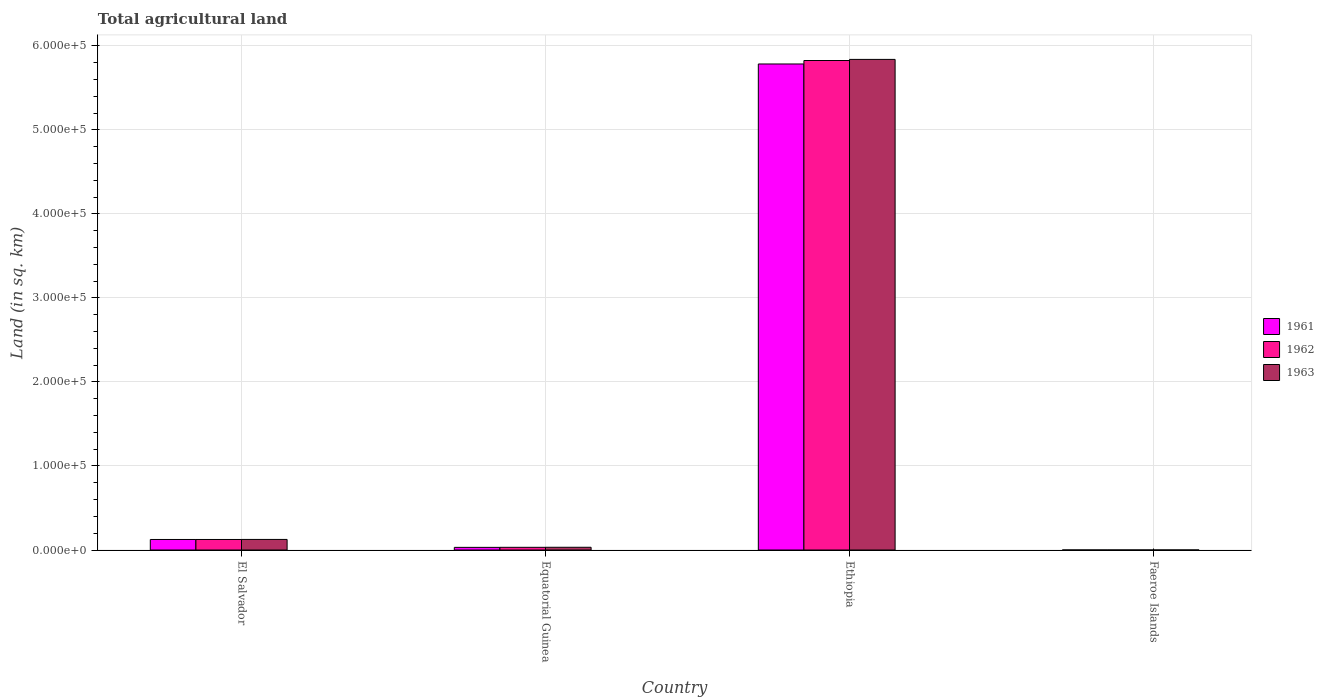How many different coloured bars are there?
Offer a terse response. 3. How many groups of bars are there?
Provide a short and direct response. 4. Are the number of bars per tick equal to the number of legend labels?
Your answer should be compact. Yes. Are the number of bars on each tick of the X-axis equal?
Offer a terse response. Yes. How many bars are there on the 1st tick from the left?
Offer a very short reply. 3. How many bars are there on the 3rd tick from the right?
Your answer should be compact. 3. What is the label of the 2nd group of bars from the left?
Keep it short and to the point. Equatorial Guinea. In how many cases, is the number of bars for a given country not equal to the number of legend labels?
Your answer should be very brief. 0. What is the total agricultural land in 1963 in Equatorial Guinea?
Keep it short and to the point. 3240. Across all countries, what is the maximum total agricultural land in 1963?
Provide a succinct answer. 5.84e+05. Across all countries, what is the minimum total agricultural land in 1961?
Your answer should be compact. 30. In which country was the total agricultural land in 1963 maximum?
Your response must be concise. Ethiopia. In which country was the total agricultural land in 1962 minimum?
Your response must be concise. Faeroe Islands. What is the total total agricultural land in 1963 in the graph?
Your answer should be very brief. 6.00e+05. What is the difference between the total agricultural land in 1963 in El Salvador and that in Faeroe Islands?
Provide a short and direct response. 1.26e+04. What is the difference between the total agricultural land in 1961 in Faeroe Islands and the total agricultural land in 1962 in El Salvador?
Provide a succinct answer. -1.25e+04. What is the average total agricultural land in 1961 per country?
Provide a succinct answer. 1.49e+05. What is the difference between the total agricultural land of/in 1961 and total agricultural land of/in 1963 in Equatorial Guinea?
Offer a terse response. -100. In how many countries, is the total agricultural land in 1962 greater than 120000 sq.km?
Your answer should be compact. 1. What is the ratio of the total agricultural land in 1962 in Equatorial Guinea to that in Ethiopia?
Provide a short and direct response. 0.01. Is the total agricultural land in 1963 in Equatorial Guinea less than that in Ethiopia?
Your answer should be compact. Yes. Is the difference between the total agricultural land in 1961 in Equatorial Guinea and Ethiopia greater than the difference between the total agricultural land in 1963 in Equatorial Guinea and Ethiopia?
Provide a short and direct response. Yes. What is the difference between the highest and the second highest total agricultural land in 1963?
Offer a terse response. 5.71e+05. What is the difference between the highest and the lowest total agricultural land in 1962?
Offer a terse response. 5.82e+05. In how many countries, is the total agricultural land in 1963 greater than the average total agricultural land in 1963 taken over all countries?
Provide a short and direct response. 1. Is the sum of the total agricultural land in 1961 in El Salvador and Faeroe Islands greater than the maximum total agricultural land in 1962 across all countries?
Your answer should be very brief. No. Is it the case that in every country, the sum of the total agricultural land in 1962 and total agricultural land in 1961 is greater than the total agricultural land in 1963?
Your answer should be very brief. Yes. Are all the bars in the graph horizontal?
Provide a succinct answer. No. How many countries are there in the graph?
Offer a terse response. 4. Are the values on the major ticks of Y-axis written in scientific E-notation?
Your answer should be very brief. Yes. Does the graph contain grids?
Provide a succinct answer. Yes. Where does the legend appear in the graph?
Ensure brevity in your answer.  Center right. How many legend labels are there?
Your answer should be very brief. 3. What is the title of the graph?
Offer a terse response. Total agricultural land. Does "1967" appear as one of the legend labels in the graph?
Your answer should be very brief. No. What is the label or title of the Y-axis?
Your answer should be very brief. Land (in sq. km). What is the Land (in sq. km) in 1961 in El Salvador?
Give a very brief answer. 1.25e+04. What is the Land (in sq. km) in 1962 in El Salvador?
Make the answer very short. 1.25e+04. What is the Land (in sq. km) in 1963 in El Salvador?
Offer a terse response. 1.26e+04. What is the Land (in sq. km) in 1961 in Equatorial Guinea?
Offer a terse response. 3140. What is the Land (in sq. km) of 1962 in Equatorial Guinea?
Provide a succinct answer. 3190. What is the Land (in sq. km) in 1963 in Equatorial Guinea?
Give a very brief answer. 3240. What is the Land (in sq. km) in 1961 in Ethiopia?
Your answer should be compact. 5.78e+05. What is the Land (in sq. km) of 1962 in Ethiopia?
Provide a succinct answer. 5.82e+05. What is the Land (in sq. km) of 1963 in Ethiopia?
Provide a succinct answer. 5.84e+05. What is the Land (in sq. km) of 1962 in Faeroe Islands?
Your response must be concise. 30. What is the Land (in sq. km) in 1963 in Faeroe Islands?
Offer a terse response. 30. Across all countries, what is the maximum Land (in sq. km) of 1961?
Give a very brief answer. 5.78e+05. Across all countries, what is the maximum Land (in sq. km) in 1962?
Make the answer very short. 5.82e+05. Across all countries, what is the maximum Land (in sq. km) in 1963?
Your answer should be compact. 5.84e+05. Across all countries, what is the minimum Land (in sq. km) in 1961?
Keep it short and to the point. 30. Across all countries, what is the minimum Land (in sq. km) in 1963?
Provide a short and direct response. 30. What is the total Land (in sq. km) in 1961 in the graph?
Your answer should be compact. 5.94e+05. What is the total Land (in sq. km) in 1962 in the graph?
Your response must be concise. 5.98e+05. What is the total Land (in sq. km) of 1963 in the graph?
Your response must be concise. 6.00e+05. What is the difference between the Land (in sq. km) of 1961 in El Salvador and that in Equatorial Guinea?
Give a very brief answer. 9380. What is the difference between the Land (in sq. km) of 1962 in El Salvador and that in Equatorial Guinea?
Keep it short and to the point. 9330. What is the difference between the Land (in sq. km) in 1963 in El Salvador and that in Equatorial Guinea?
Offer a terse response. 9340. What is the difference between the Land (in sq. km) in 1961 in El Salvador and that in Ethiopia?
Provide a short and direct response. -5.66e+05. What is the difference between the Land (in sq. km) in 1962 in El Salvador and that in Ethiopia?
Offer a very short reply. -5.70e+05. What is the difference between the Land (in sq. km) in 1963 in El Salvador and that in Ethiopia?
Keep it short and to the point. -5.71e+05. What is the difference between the Land (in sq. km) of 1961 in El Salvador and that in Faeroe Islands?
Offer a very short reply. 1.25e+04. What is the difference between the Land (in sq. km) in 1962 in El Salvador and that in Faeroe Islands?
Offer a very short reply. 1.25e+04. What is the difference between the Land (in sq. km) in 1963 in El Salvador and that in Faeroe Islands?
Offer a terse response. 1.26e+04. What is the difference between the Land (in sq. km) in 1961 in Equatorial Guinea and that in Ethiopia?
Offer a very short reply. -5.75e+05. What is the difference between the Land (in sq. km) of 1962 in Equatorial Guinea and that in Ethiopia?
Offer a very short reply. -5.79e+05. What is the difference between the Land (in sq. km) of 1963 in Equatorial Guinea and that in Ethiopia?
Give a very brief answer. -5.81e+05. What is the difference between the Land (in sq. km) in 1961 in Equatorial Guinea and that in Faeroe Islands?
Give a very brief answer. 3110. What is the difference between the Land (in sq. km) in 1962 in Equatorial Guinea and that in Faeroe Islands?
Offer a terse response. 3160. What is the difference between the Land (in sq. km) of 1963 in Equatorial Guinea and that in Faeroe Islands?
Give a very brief answer. 3210. What is the difference between the Land (in sq. km) of 1961 in Ethiopia and that in Faeroe Islands?
Provide a succinct answer. 5.78e+05. What is the difference between the Land (in sq. km) in 1962 in Ethiopia and that in Faeroe Islands?
Your answer should be compact. 5.82e+05. What is the difference between the Land (in sq. km) of 1963 in Ethiopia and that in Faeroe Islands?
Offer a very short reply. 5.84e+05. What is the difference between the Land (in sq. km) in 1961 in El Salvador and the Land (in sq. km) in 1962 in Equatorial Guinea?
Ensure brevity in your answer.  9330. What is the difference between the Land (in sq. km) of 1961 in El Salvador and the Land (in sq. km) of 1963 in Equatorial Guinea?
Your response must be concise. 9280. What is the difference between the Land (in sq. km) of 1962 in El Salvador and the Land (in sq. km) of 1963 in Equatorial Guinea?
Your answer should be compact. 9280. What is the difference between the Land (in sq. km) of 1961 in El Salvador and the Land (in sq. km) of 1962 in Ethiopia?
Provide a short and direct response. -5.70e+05. What is the difference between the Land (in sq. km) of 1961 in El Salvador and the Land (in sq. km) of 1963 in Ethiopia?
Your answer should be compact. -5.71e+05. What is the difference between the Land (in sq. km) of 1962 in El Salvador and the Land (in sq. km) of 1963 in Ethiopia?
Give a very brief answer. -5.71e+05. What is the difference between the Land (in sq. km) of 1961 in El Salvador and the Land (in sq. km) of 1962 in Faeroe Islands?
Make the answer very short. 1.25e+04. What is the difference between the Land (in sq. km) in 1961 in El Salvador and the Land (in sq. km) in 1963 in Faeroe Islands?
Offer a terse response. 1.25e+04. What is the difference between the Land (in sq. km) in 1962 in El Salvador and the Land (in sq. km) in 1963 in Faeroe Islands?
Offer a terse response. 1.25e+04. What is the difference between the Land (in sq. km) of 1961 in Equatorial Guinea and the Land (in sq. km) of 1962 in Ethiopia?
Offer a very short reply. -5.79e+05. What is the difference between the Land (in sq. km) in 1961 in Equatorial Guinea and the Land (in sq. km) in 1963 in Ethiopia?
Ensure brevity in your answer.  -5.81e+05. What is the difference between the Land (in sq. km) in 1962 in Equatorial Guinea and the Land (in sq. km) in 1963 in Ethiopia?
Provide a short and direct response. -5.81e+05. What is the difference between the Land (in sq. km) of 1961 in Equatorial Guinea and the Land (in sq. km) of 1962 in Faeroe Islands?
Offer a terse response. 3110. What is the difference between the Land (in sq. km) in 1961 in Equatorial Guinea and the Land (in sq. km) in 1963 in Faeroe Islands?
Your answer should be compact. 3110. What is the difference between the Land (in sq. km) in 1962 in Equatorial Guinea and the Land (in sq. km) in 1963 in Faeroe Islands?
Offer a terse response. 3160. What is the difference between the Land (in sq. km) of 1961 in Ethiopia and the Land (in sq. km) of 1962 in Faeroe Islands?
Ensure brevity in your answer.  5.78e+05. What is the difference between the Land (in sq. km) of 1961 in Ethiopia and the Land (in sq. km) of 1963 in Faeroe Islands?
Offer a terse response. 5.78e+05. What is the difference between the Land (in sq. km) of 1962 in Ethiopia and the Land (in sq. km) of 1963 in Faeroe Islands?
Give a very brief answer. 5.82e+05. What is the average Land (in sq. km) of 1961 per country?
Your response must be concise. 1.49e+05. What is the average Land (in sq. km) in 1962 per country?
Your response must be concise. 1.50e+05. What is the average Land (in sq. km) of 1963 per country?
Offer a terse response. 1.50e+05. What is the difference between the Land (in sq. km) in 1961 and Land (in sq. km) in 1962 in El Salvador?
Make the answer very short. 0. What is the difference between the Land (in sq. km) of 1961 and Land (in sq. km) of 1963 in El Salvador?
Keep it short and to the point. -60. What is the difference between the Land (in sq. km) of 1962 and Land (in sq. km) of 1963 in El Salvador?
Offer a very short reply. -60. What is the difference between the Land (in sq. km) of 1961 and Land (in sq. km) of 1962 in Equatorial Guinea?
Your answer should be very brief. -50. What is the difference between the Land (in sq. km) of 1961 and Land (in sq. km) of 1963 in Equatorial Guinea?
Offer a very short reply. -100. What is the difference between the Land (in sq. km) of 1961 and Land (in sq. km) of 1962 in Ethiopia?
Offer a terse response. -4130. What is the difference between the Land (in sq. km) in 1961 and Land (in sq. km) in 1963 in Ethiopia?
Your answer should be compact. -5440. What is the difference between the Land (in sq. km) in 1962 and Land (in sq. km) in 1963 in Ethiopia?
Keep it short and to the point. -1310. What is the difference between the Land (in sq. km) in 1961 and Land (in sq. km) in 1963 in Faeroe Islands?
Your answer should be compact. 0. What is the ratio of the Land (in sq. km) of 1961 in El Salvador to that in Equatorial Guinea?
Make the answer very short. 3.99. What is the ratio of the Land (in sq. km) of 1962 in El Salvador to that in Equatorial Guinea?
Offer a terse response. 3.92. What is the ratio of the Land (in sq. km) in 1963 in El Salvador to that in Equatorial Guinea?
Your answer should be very brief. 3.88. What is the ratio of the Land (in sq. km) of 1961 in El Salvador to that in Ethiopia?
Give a very brief answer. 0.02. What is the ratio of the Land (in sq. km) in 1962 in El Salvador to that in Ethiopia?
Provide a short and direct response. 0.02. What is the ratio of the Land (in sq. km) in 1963 in El Salvador to that in Ethiopia?
Your answer should be very brief. 0.02. What is the ratio of the Land (in sq. km) of 1961 in El Salvador to that in Faeroe Islands?
Ensure brevity in your answer.  417.33. What is the ratio of the Land (in sq. km) of 1962 in El Salvador to that in Faeroe Islands?
Your response must be concise. 417.33. What is the ratio of the Land (in sq. km) in 1963 in El Salvador to that in Faeroe Islands?
Provide a succinct answer. 419.33. What is the ratio of the Land (in sq. km) in 1961 in Equatorial Guinea to that in Ethiopia?
Offer a terse response. 0.01. What is the ratio of the Land (in sq. km) of 1962 in Equatorial Guinea to that in Ethiopia?
Keep it short and to the point. 0.01. What is the ratio of the Land (in sq. km) in 1963 in Equatorial Guinea to that in Ethiopia?
Make the answer very short. 0.01. What is the ratio of the Land (in sq. km) in 1961 in Equatorial Guinea to that in Faeroe Islands?
Your answer should be compact. 104.67. What is the ratio of the Land (in sq. km) of 1962 in Equatorial Guinea to that in Faeroe Islands?
Provide a short and direct response. 106.33. What is the ratio of the Land (in sq. km) of 1963 in Equatorial Guinea to that in Faeroe Islands?
Offer a terse response. 108. What is the ratio of the Land (in sq. km) of 1961 in Ethiopia to that in Faeroe Islands?
Ensure brevity in your answer.  1.93e+04. What is the ratio of the Land (in sq. km) of 1962 in Ethiopia to that in Faeroe Islands?
Offer a terse response. 1.94e+04. What is the ratio of the Land (in sq. km) in 1963 in Ethiopia to that in Faeroe Islands?
Provide a short and direct response. 1.95e+04. What is the difference between the highest and the second highest Land (in sq. km) of 1961?
Your response must be concise. 5.66e+05. What is the difference between the highest and the second highest Land (in sq. km) of 1962?
Keep it short and to the point. 5.70e+05. What is the difference between the highest and the second highest Land (in sq. km) of 1963?
Make the answer very short. 5.71e+05. What is the difference between the highest and the lowest Land (in sq. km) in 1961?
Give a very brief answer. 5.78e+05. What is the difference between the highest and the lowest Land (in sq. km) in 1962?
Your response must be concise. 5.82e+05. What is the difference between the highest and the lowest Land (in sq. km) of 1963?
Offer a very short reply. 5.84e+05. 